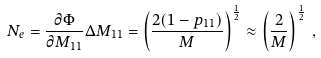<formula> <loc_0><loc_0><loc_500><loc_500>N _ { e } = \frac { \partial \Phi } { \partial M _ { 1 1 } } \Delta M _ { 1 1 } = \left ( \frac { 2 ( 1 - p _ { 1 1 } ) } { M } \right ) ^ { \frac { 1 } { 2 } } \approx \left ( \frac { 2 } { M } \right ) ^ { \frac { 1 } { 2 } } \, ,</formula> 